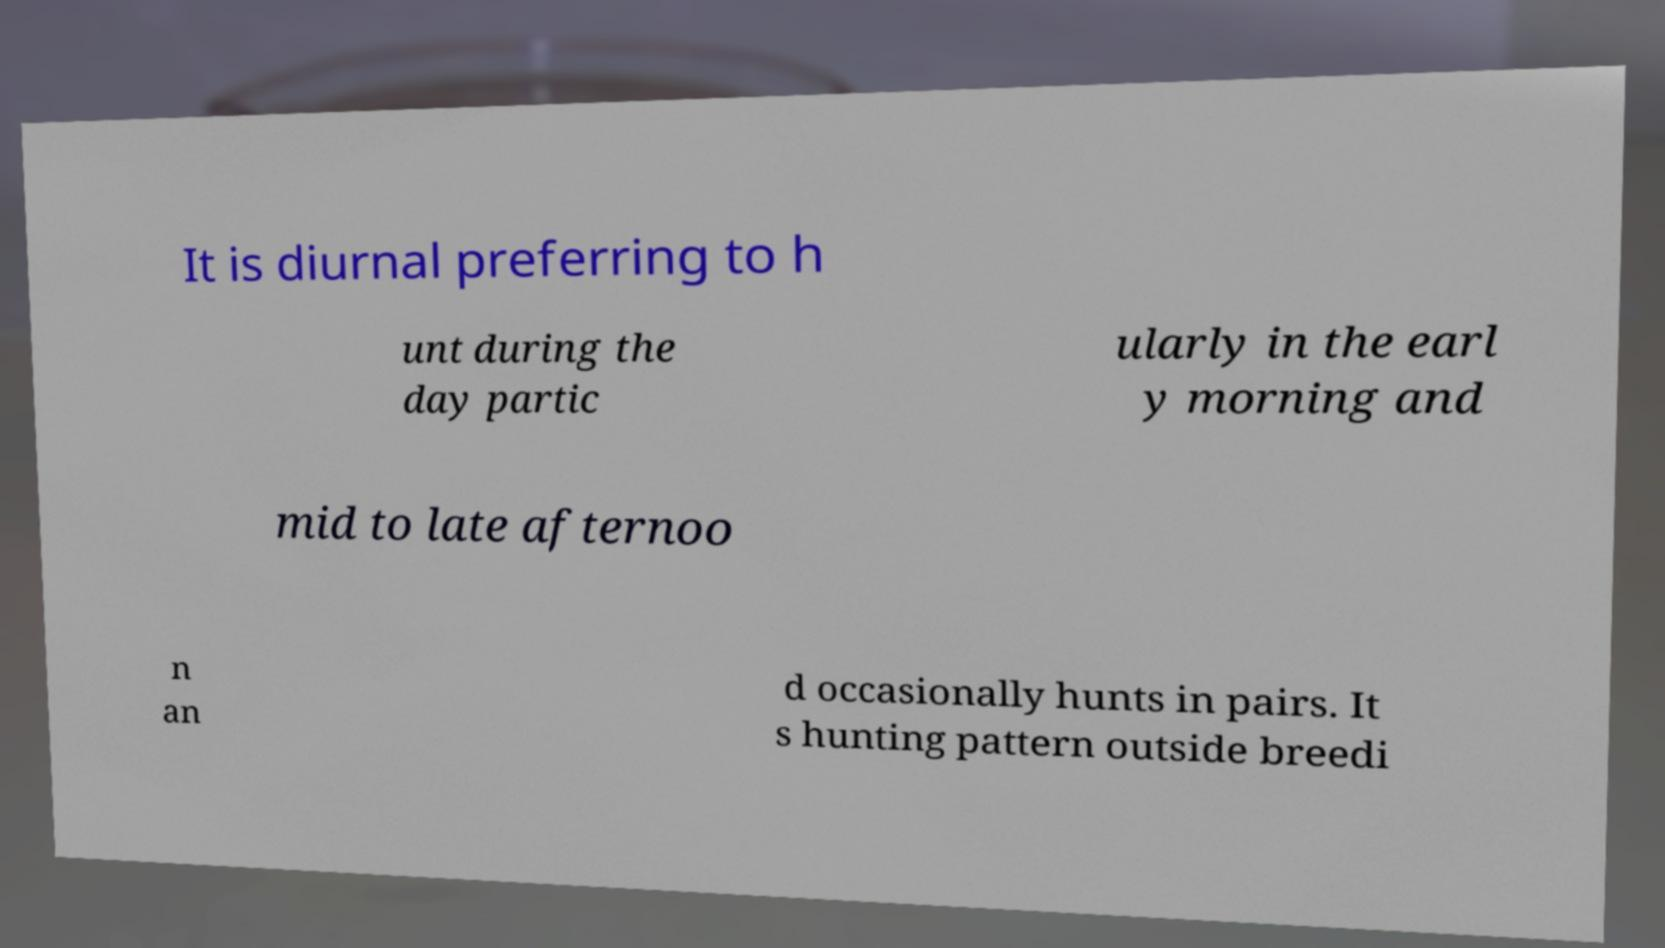Can you accurately transcribe the text from the provided image for me? It is diurnal preferring to h unt during the day partic ularly in the earl y morning and mid to late afternoo n an d occasionally hunts in pairs. It s hunting pattern outside breedi 